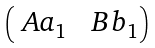Convert formula to latex. <formula><loc_0><loc_0><loc_500><loc_500>\begin{pmatrix} \ A a _ { 1 } & \ B b _ { 1 } \end{pmatrix}</formula> 